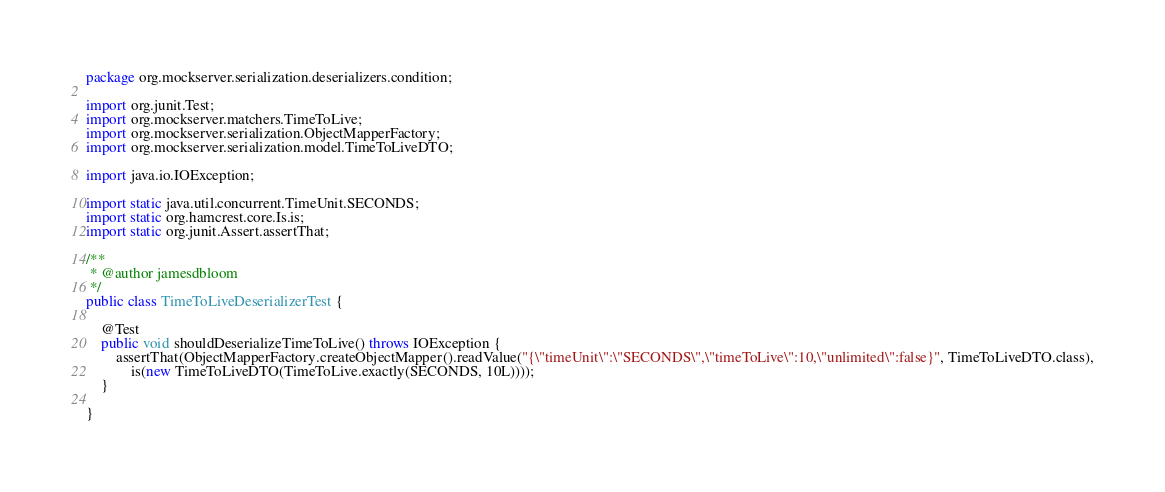<code> <loc_0><loc_0><loc_500><loc_500><_Java_>package org.mockserver.serialization.deserializers.condition;

import org.junit.Test;
import org.mockserver.matchers.TimeToLive;
import org.mockserver.serialization.ObjectMapperFactory;
import org.mockserver.serialization.model.TimeToLiveDTO;

import java.io.IOException;

import static java.util.concurrent.TimeUnit.SECONDS;
import static org.hamcrest.core.Is.is;
import static org.junit.Assert.assertThat;

/**
 * @author jamesdbloom
 */
public class TimeToLiveDeserializerTest {

    @Test
    public void shouldDeserializeTimeToLive() throws IOException {
        assertThat(ObjectMapperFactory.createObjectMapper().readValue("{\"timeUnit\":\"SECONDS\",\"timeToLive\":10,\"unlimited\":false}", TimeToLiveDTO.class),
            is(new TimeToLiveDTO(TimeToLive.exactly(SECONDS, 10L))));
    }

}
</code> 